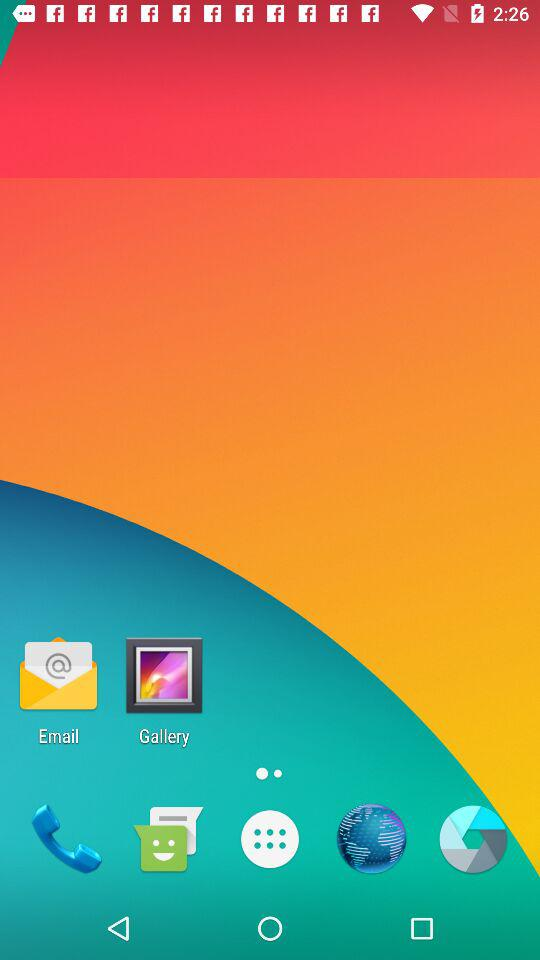How many text-to-speech engines are available?
Answer the question using a single word or phrase. 2 